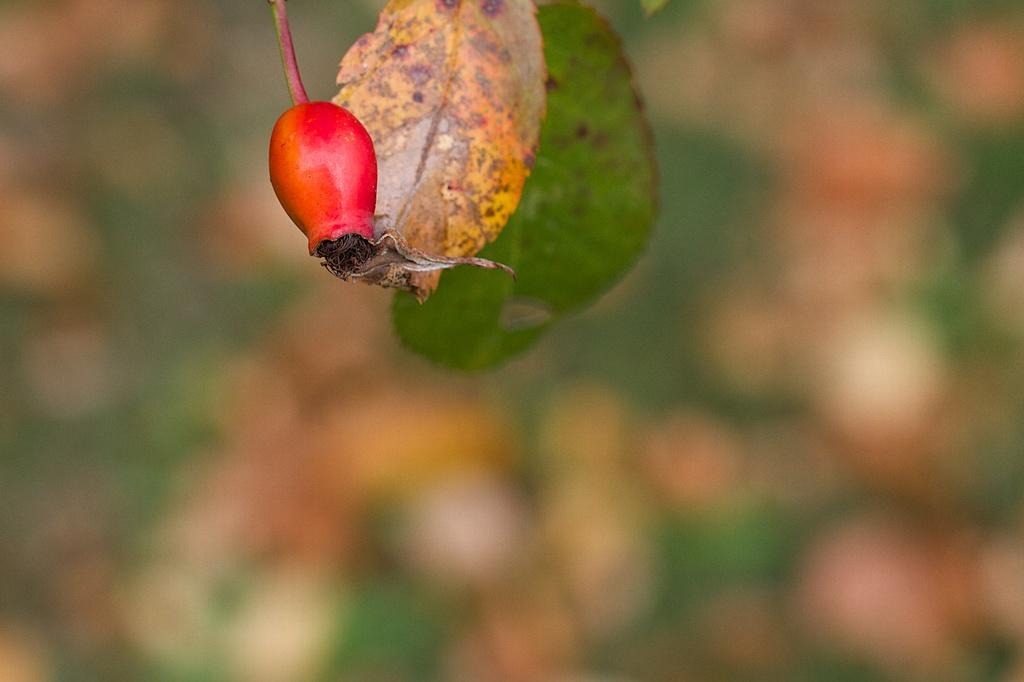What type of food is present in the image? There is a fruit in the image. Can you describe the background of the image? The background of the image is blurry. What type of sponge can be seen bursting in the image? There is no sponge or bursting action present in the image; it features a fruit with a blurry background. 